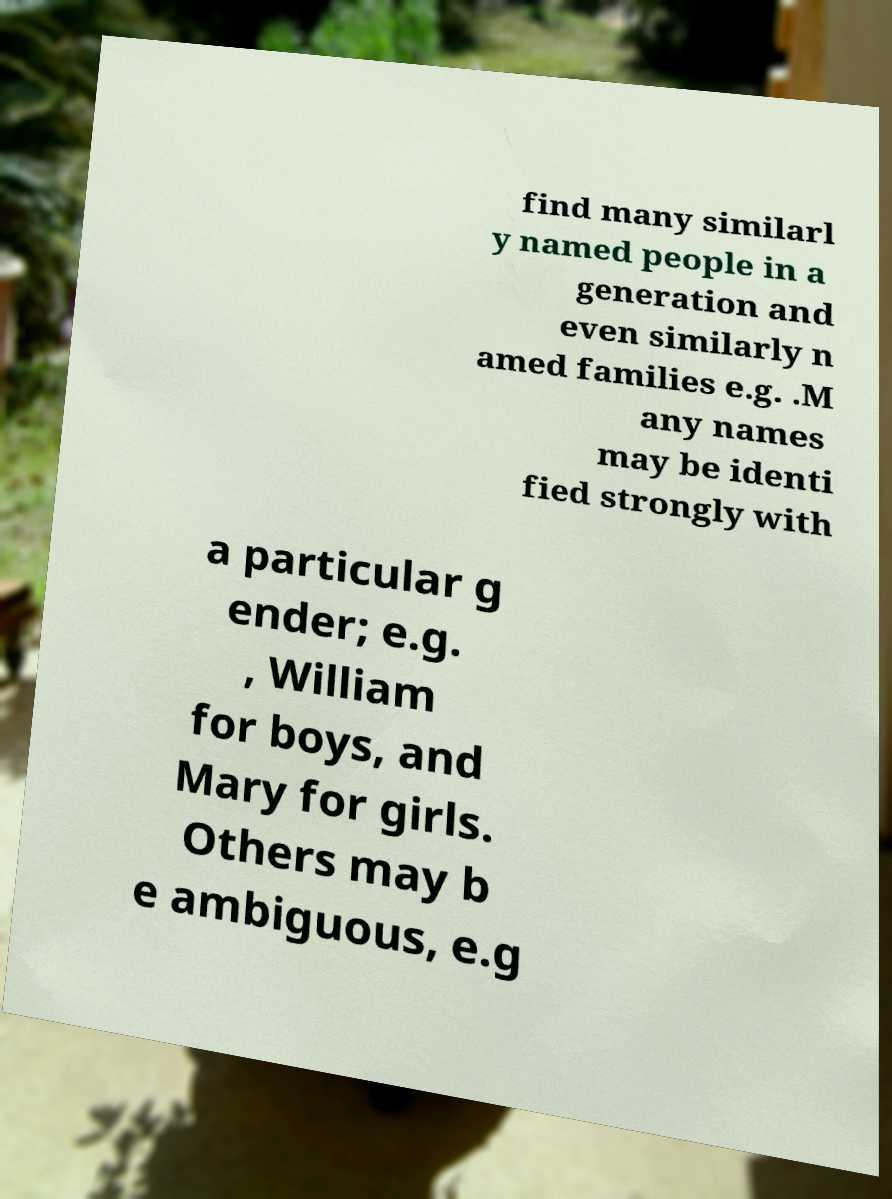Can you accurately transcribe the text from the provided image for me? find many similarl y named people in a generation and even similarly n amed families e.g. .M any names may be identi fied strongly with a particular g ender; e.g. , William for boys, and Mary for girls. Others may b e ambiguous, e.g 